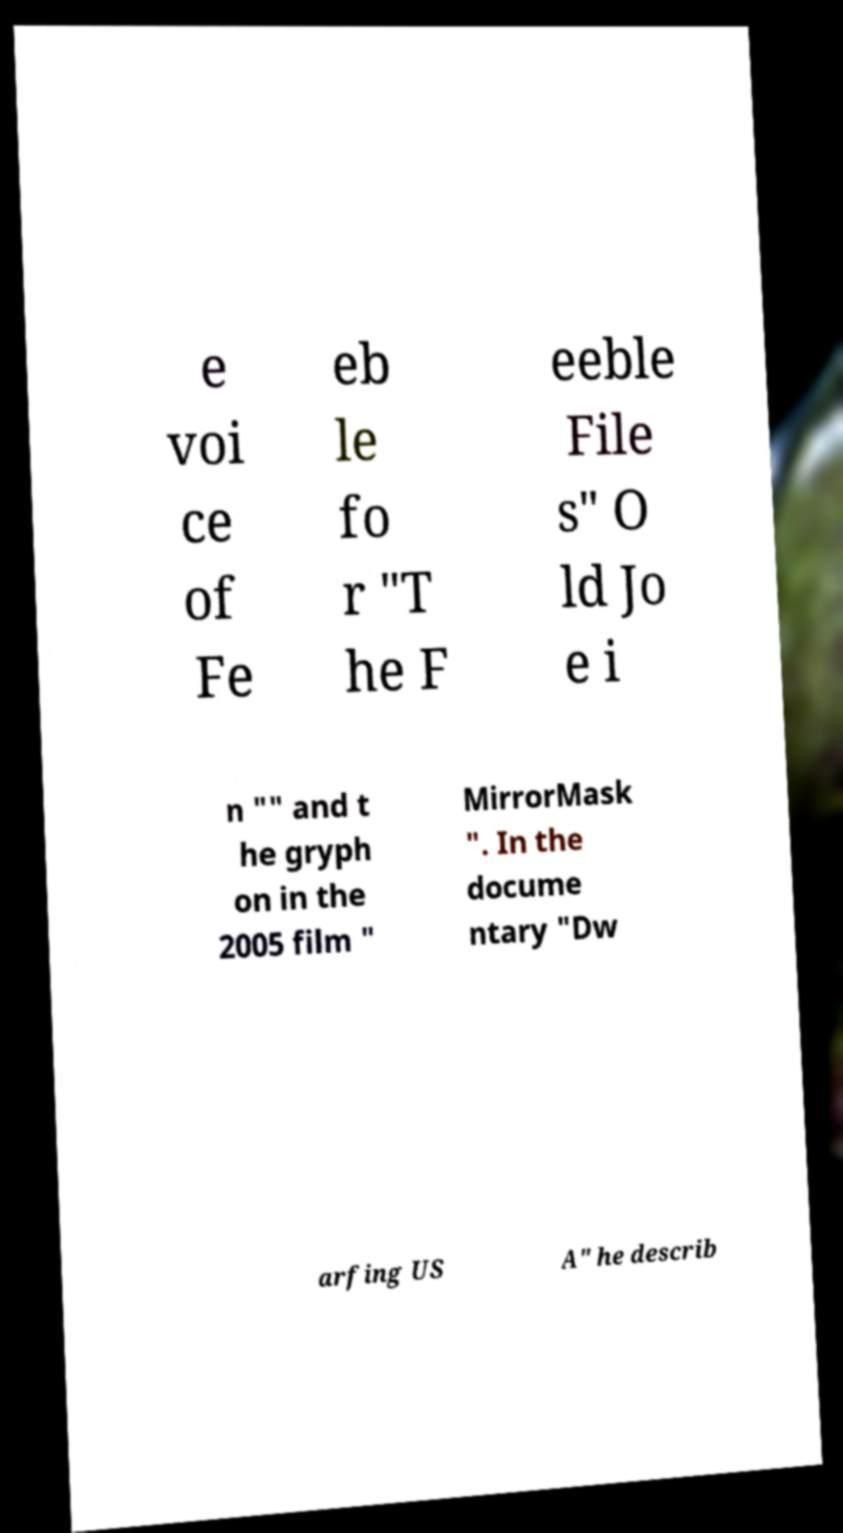There's text embedded in this image that I need extracted. Can you transcribe it verbatim? e voi ce of Fe eb le fo r "T he F eeble File s" O ld Jo e i n "" and t he gryph on in the 2005 film " MirrorMask ". In the docume ntary "Dw arfing US A" he describ 